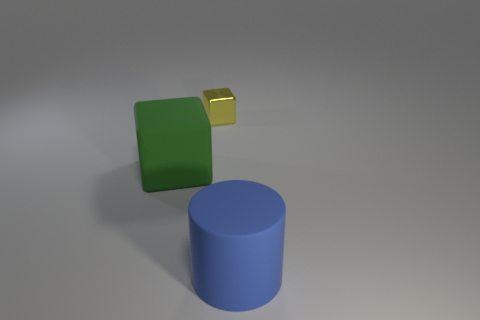Is the blue cylinder made of the same material as the large green thing?
Keep it short and to the point. Yes. What is the size of the blue matte cylinder?
Offer a terse response. Large. How many objects are tiny metallic blocks or big objects?
Your answer should be very brief. 3. Are the thing in front of the big matte cube and the object to the left of the small metallic object made of the same material?
Give a very brief answer. Yes. There is a cylinder that is the same material as the large green block; what is its color?
Give a very brief answer. Blue. How many metal things have the same size as the blue rubber thing?
Ensure brevity in your answer.  0. How many other objects are the same color as the large rubber cube?
Provide a succinct answer. 0. Is there any other thing that is the same size as the shiny cube?
Your answer should be very brief. No. Is the shape of the matte thing that is behind the blue matte thing the same as the object that is behind the big green block?
Make the answer very short. Yes. There is a green matte thing that is the same size as the blue cylinder; what shape is it?
Provide a short and direct response. Cube. 